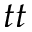<formula> <loc_0><loc_0><loc_500><loc_500>t t</formula> 